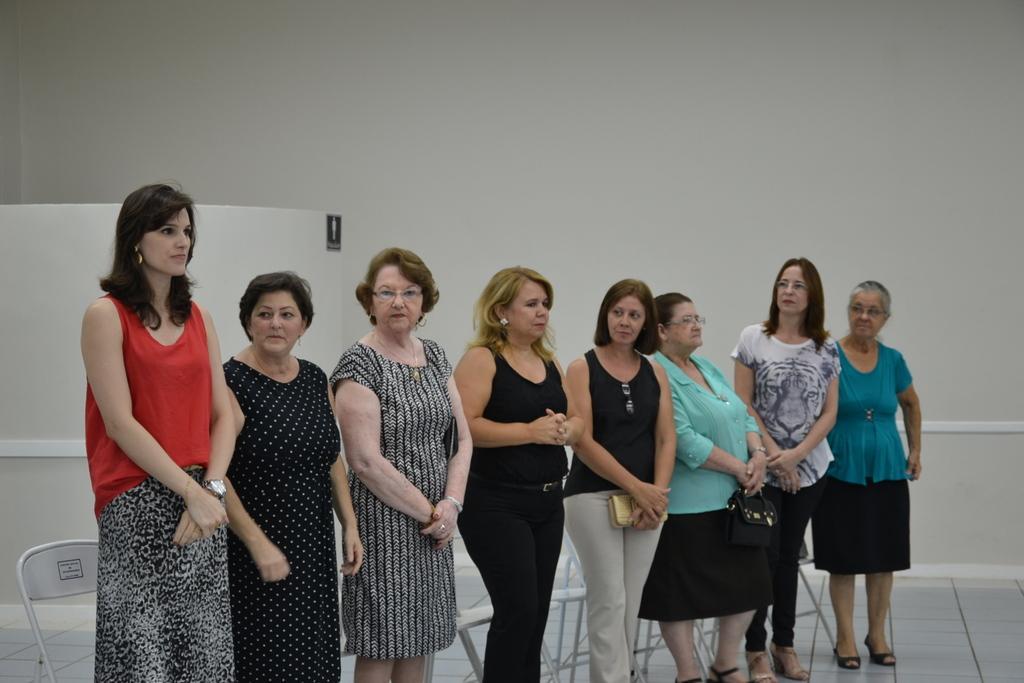Describe this image in one or two sentences. In this image in the center there are group of people who are standing and behind them there are some chairs, in the background there is a wall. At the bottom there is a floor. 